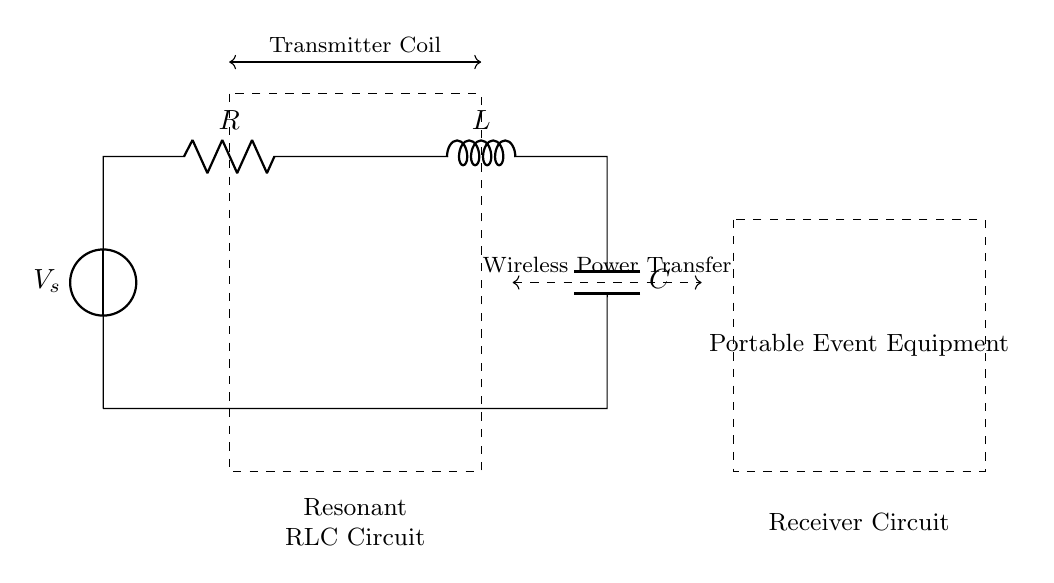What type of circuit is shown? The circuit diagram represents a resonant RLC circuit, indicated by the presence of the resistor, inductor, and capacitor components arranged in series.
Answer: resonant RLC circuit What is the purpose of the dashed rectangle on the left? The dashed rectangle encapsulates the transmitter coil, which is part of the wireless power transfer system designed to send energy wirelessly.
Answer: Transmitter Coil Which components are present in this circuit? The circuit contains a voltage source, resistor, inductor, and capacitor, all necessary for the operation of a resonant RLC circuit.
Answer: Voltage source, resistor, inductor, capacitor What does the dashed line between the left and right sections indicate? The dashed line indicates wireless power transfer occurring from the transmitter circuit to the receiver circuit, highlighting the connection in the wireless power system.
Answer: Wireless Power Transfer What role does the inductor play in this circuit? The inductor stores energy in a magnetic field when current flows through it, contributing to the resonance characteristic of this RLC circuit.
Answer: Energy storage What needs to be matched for resonance in this RLC circuit? The inductive reactance must equal the capacitive reactance for the circuit to achieve resonance, allowing maximum power transfer.
Answer: Inductive and capacitive reactance What is the significance of resonance in wireless power transfer? Resonance allows for efficient energy transfer between the transmitter and receiver, optimizing the performance of the wireless power system for portable equipment.
Answer: Efficient energy transfer 